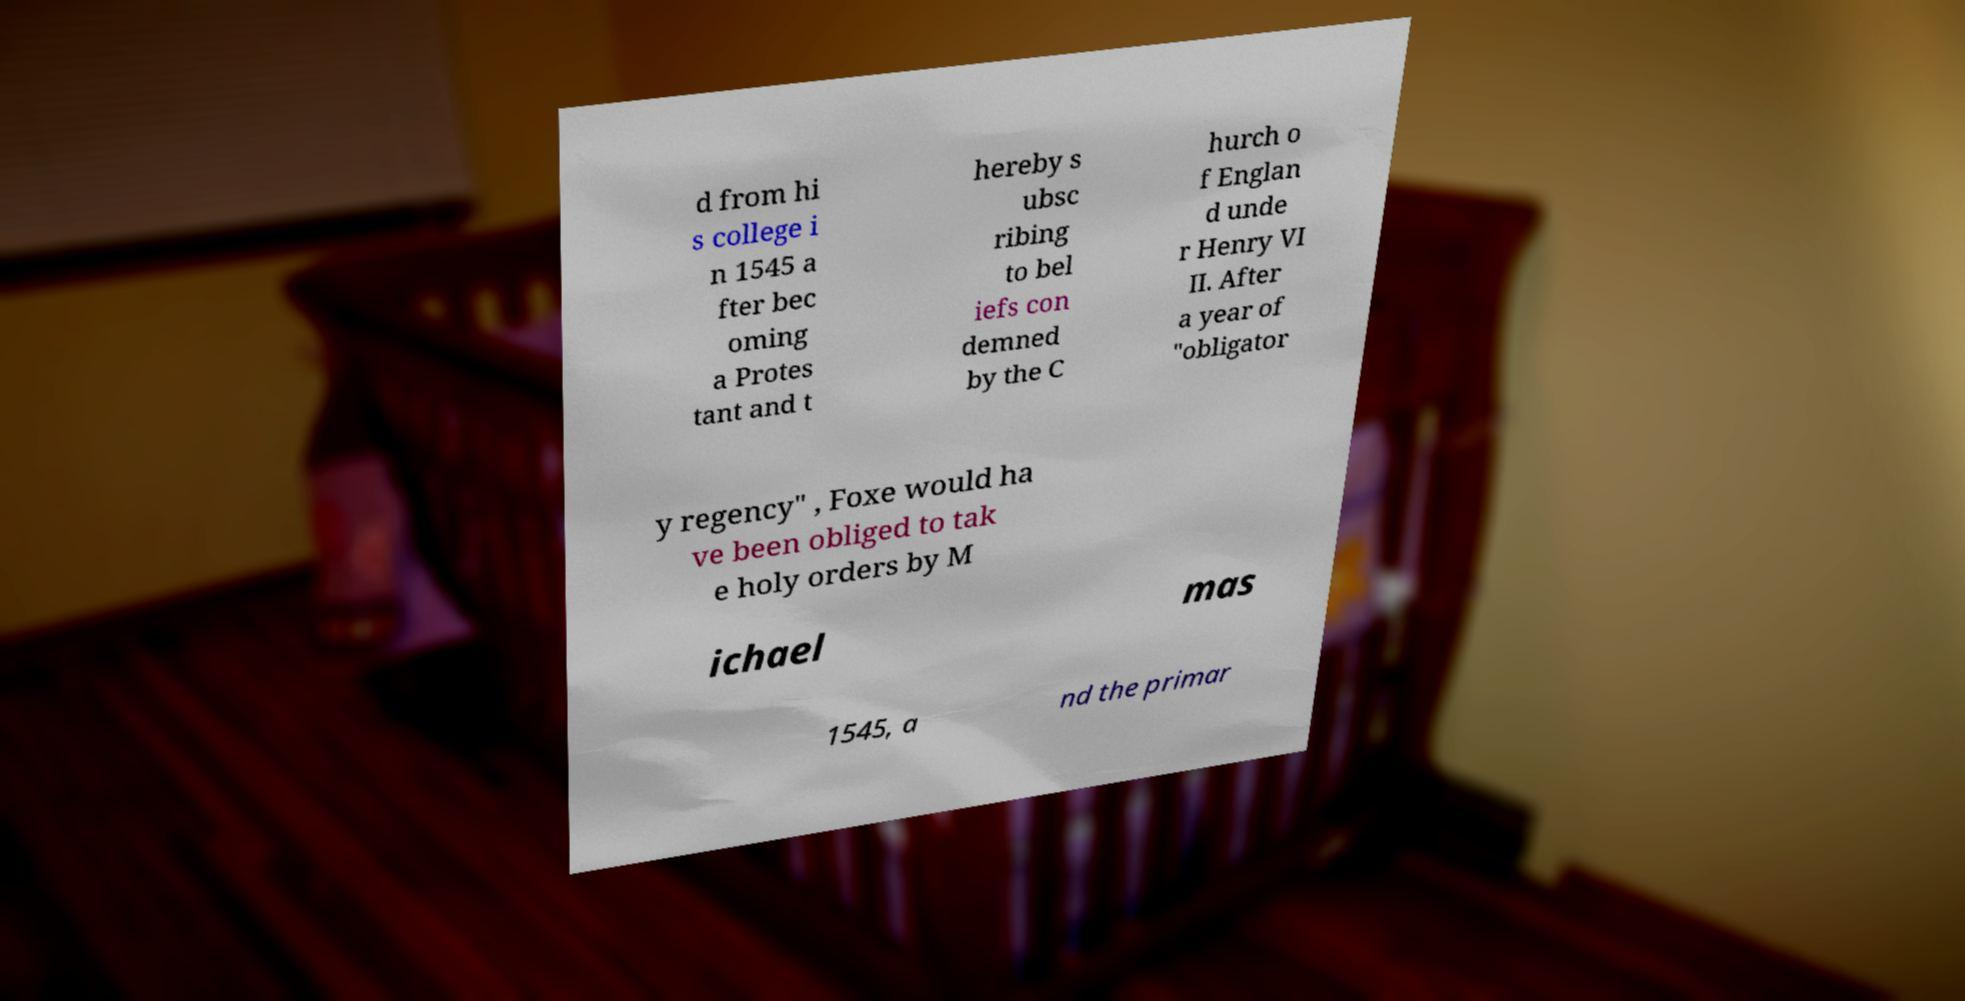I need the written content from this picture converted into text. Can you do that? d from hi s college i n 1545 a fter bec oming a Protes tant and t hereby s ubsc ribing to bel iefs con demned by the C hurch o f Englan d unde r Henry VI II. After a year of "obligator y regency" , Foxe would ha ve been obliged to tak e holy orders by M ichael mas 1545, a nd the primar 